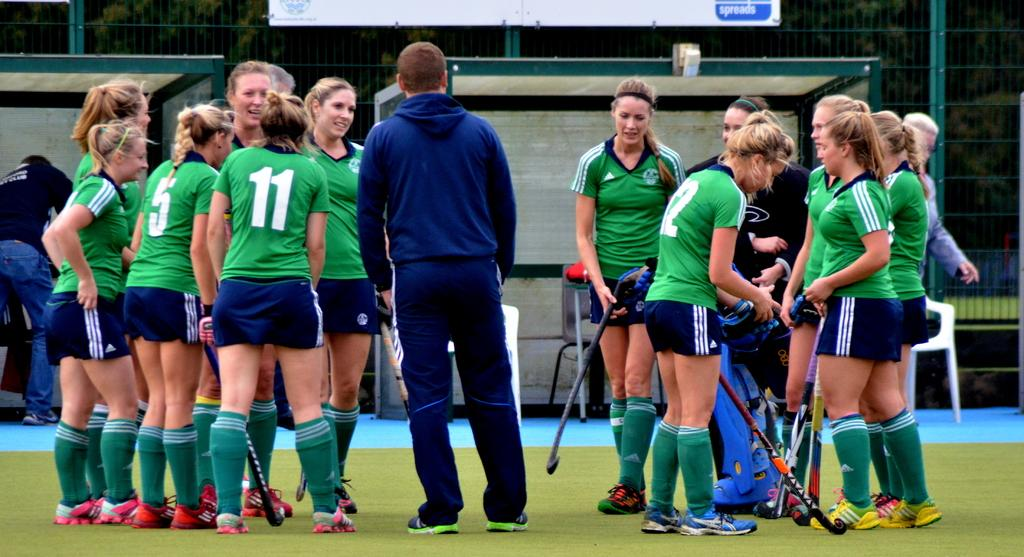<image>
Create a compact narrative representing the image presented. a bunch of female hockey players, one of whom is wearing a number 11 shirt 